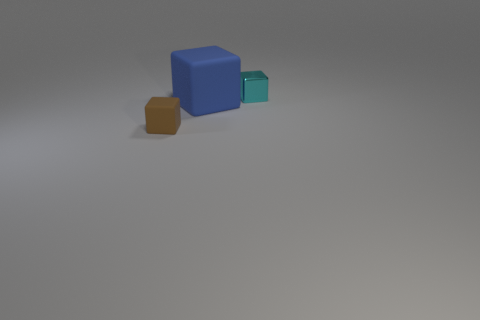Subtract all rubber cubes. How many cubes are left? 1 Add 2 big blue things. How many objects exist? 5 Subtract 2 cubes. How many cubes are left? 1 Subtract all blue blocks. Subtract all brown cylinders. How many blocks are left? 2 Subtract all cyan balls. How many gray cubes are left? 0 Add 1 cyan metallic things. How many cyan metallic things are left? 2 Add 3 large yellow matte cubes. How many large yellow matte cubes exist? 3 Subtract 0 blue cylinders. How many objects are left? 3 Subtract all big gray cubes. Subtract all tiny cubes. How many objects are left? 1 